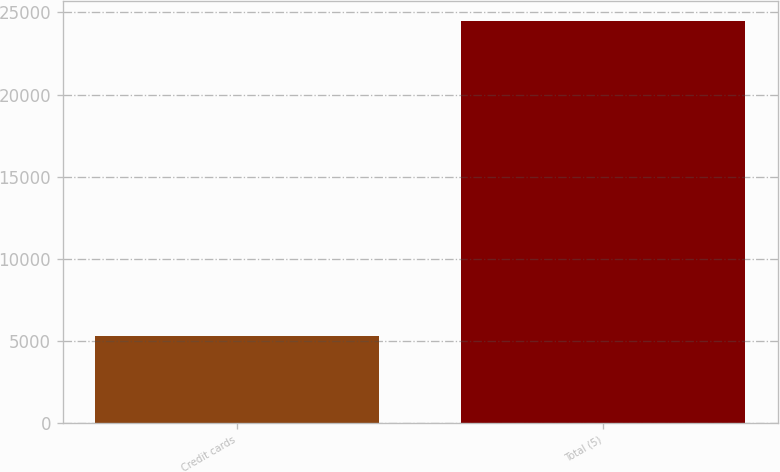Convert chart. <chart><loc_0><loc_0><loc_500><loc_500><bar_chart><fcel>Credit cards<fcel>Total (5)<nl><fcel>5314<fcel>24466<nl></chart> 